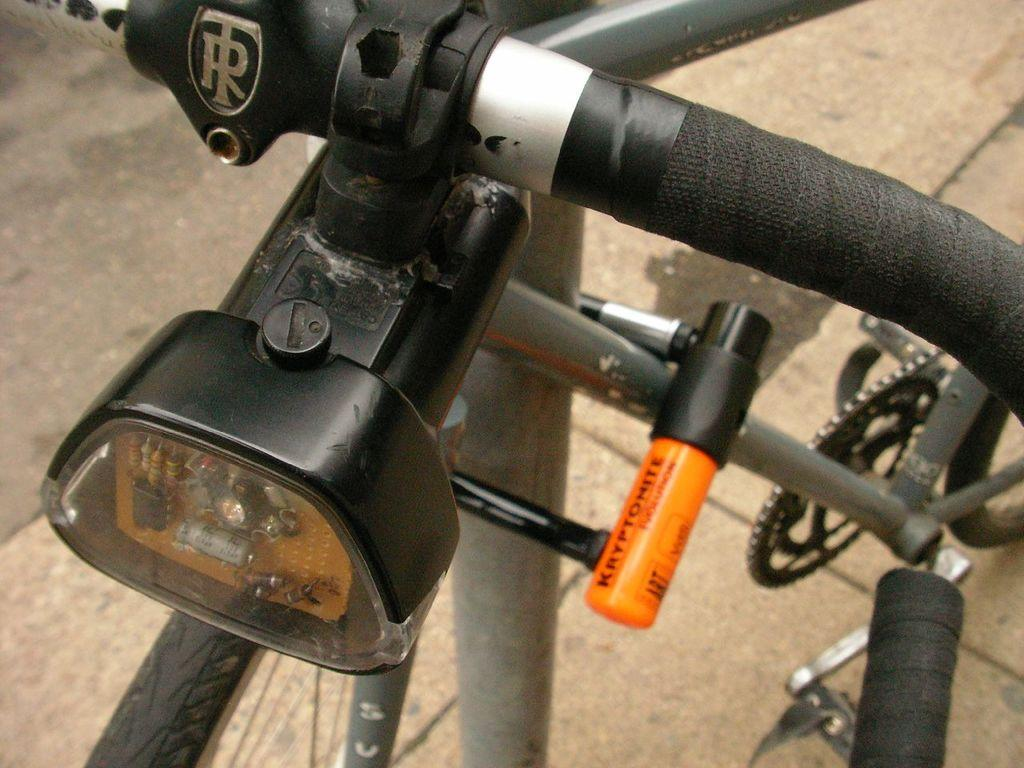What is the main object in the image? There is a bicycle in the image. How many snails are crawling on the bicycle in the image? There are no snails present in the image; it only features a bicycle. What type of tin is used to make the bicycle in the image? The image does not provide information about the materials used to make the bicycle, nor is there any tin visible. 